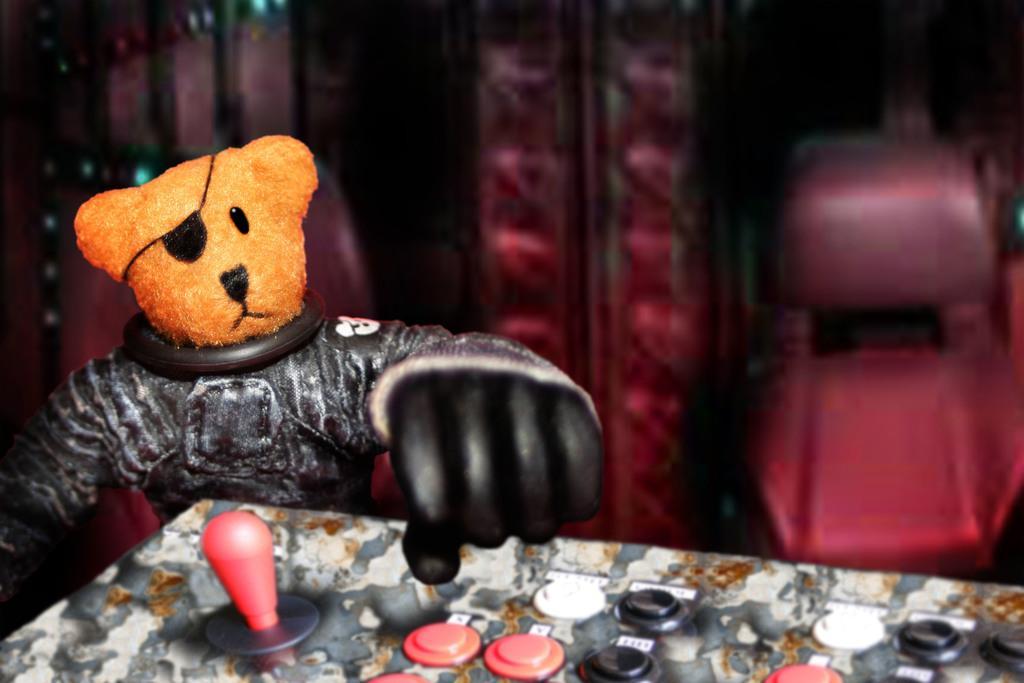Can you describe this image briefly? In this image, at the left side there is a brown color teddy bear head, at the right side background there is a red color chair. 